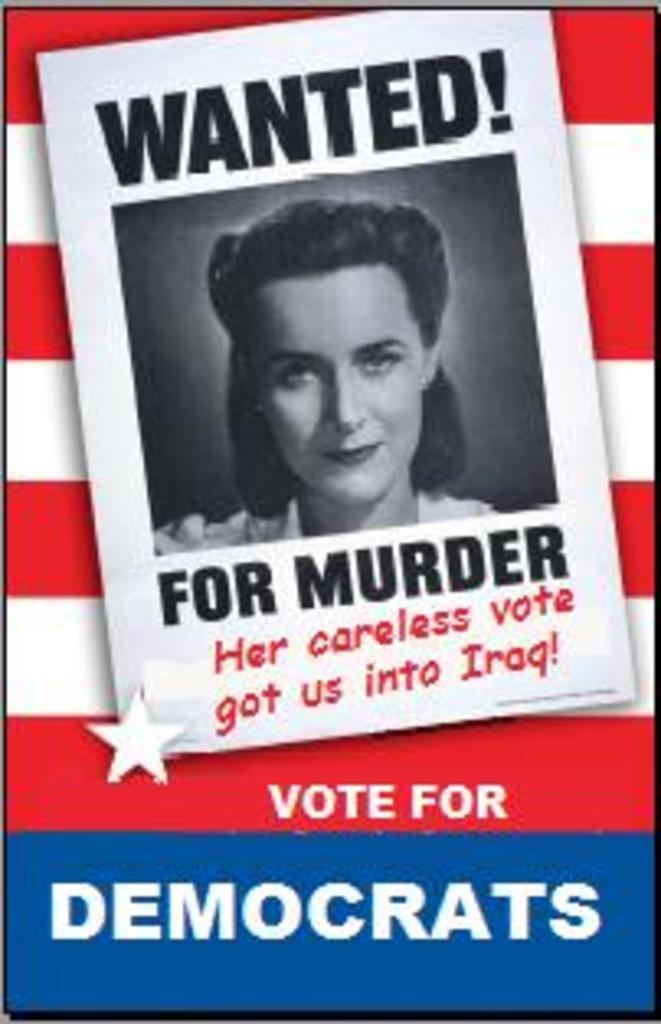Describe this image in one or two sentences. In this picture we can see a photograph of the woman. On the top we can see "Wanted" is written. 